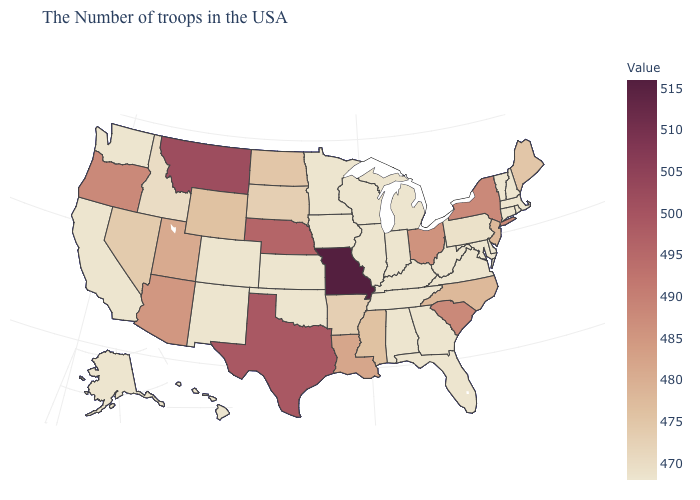Which states have the lowest value in the USA?
Quick response, please. Massachusetts, Rhode Island, New Hampshire, Vermont, Connecticut, Delaware, Maryland, Virginia, West Virginia, Florida, Georgia, Michigan, Kentucky, Indiana, Alabama, Tennessee, Wisconsin, Illinois, Minnesota, Iowa, Kansas, Oklahoma, Colorado, New Mexico, California, Washington, Alaska, Hawaii. Does the map have missing data?
Be succinct. No. Which states have the lowest value in the West?
Answer briefly. Colorado, New Mexico, California, Washington, Alaska, Hawaii. Which states have the highest value in the USA?
Short answer required. Missouri. Among the states that border New Hampshire , which have the highest value?
Answer briefly. Maine. 